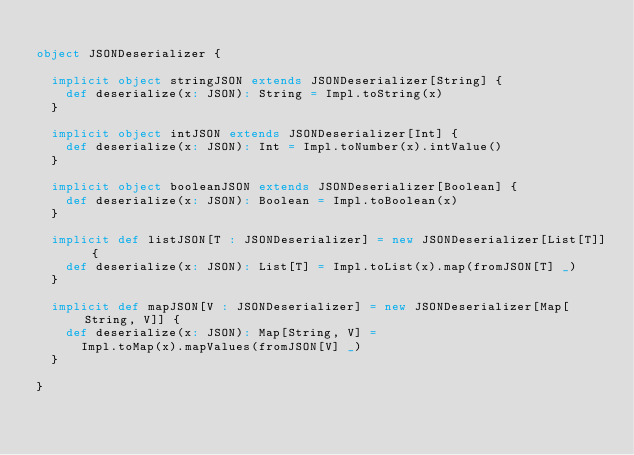Convert code to text. <code><loc_0><loc_0><loc_500><loc_500><_Scala_>
object JSONDeserializer {

  implicit object stringJSON extends JSONDeserializer[String] {
    def deserialize(x: JSON): String = Impl.toString(x)
  }

  implicit object intJSON extends JSONDeserializer[Int] {
    def deserialize(x: JSON): Int = Impl.toNumber(x).intValue()
  }

  implicit object booleanJSON extends JSONDeserializer[Boolean] {
    def deserialize(x: JSON): Boolean = Impl.toBoolean(x)
  }

  implicit def listJSON[T : JSONDeserializer] = new JSONDeserializer[List[T]] {
    def deserialize(x: JSON): List[T] = Impl.toList(x).map(fromJSON[T] _)
  }

  implicit def mapJSON[V : JSONDeserializer] = new JSONDeserializer[Map[String, V]] {
    def deserialize(x: JSON): Map[String, V] =
      Impl.toMap(x).mapValues(fromJSON[V] _)
  }

}
</code> 